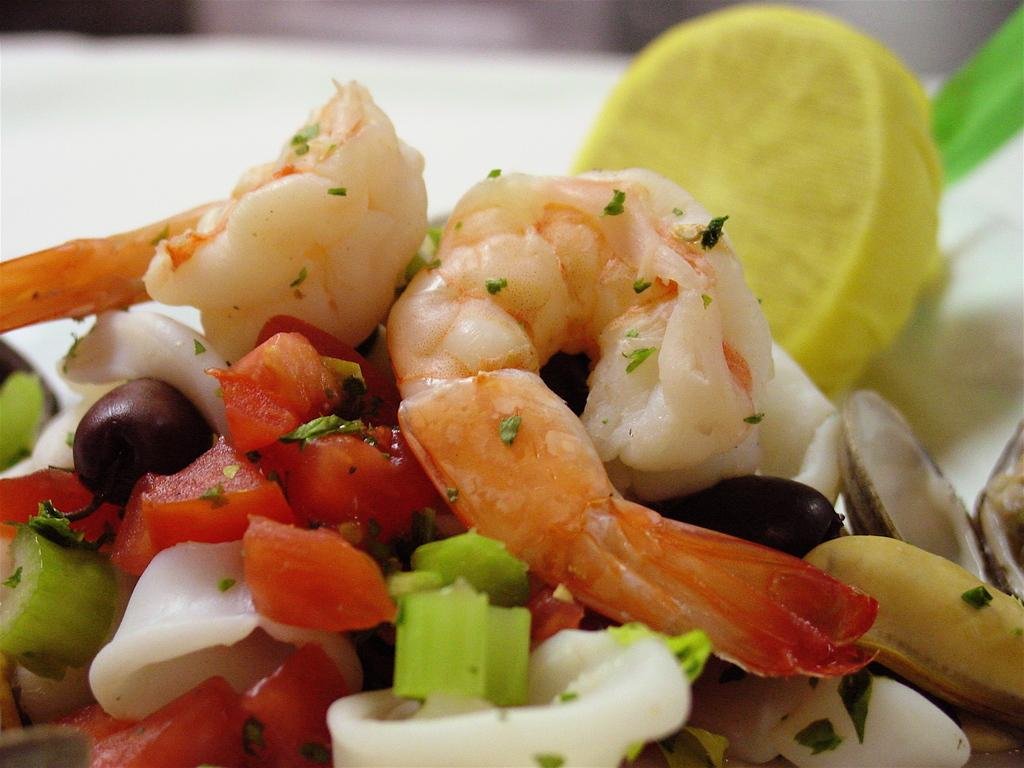What types of objects can be seen in the image? There are food items in the image. Can you describe the background of the image? The background of the image is blurry. What type of glue is being used to hold the pie together in the image? There is no pie present in the image, and therefore no glue is being used to hold it together. 